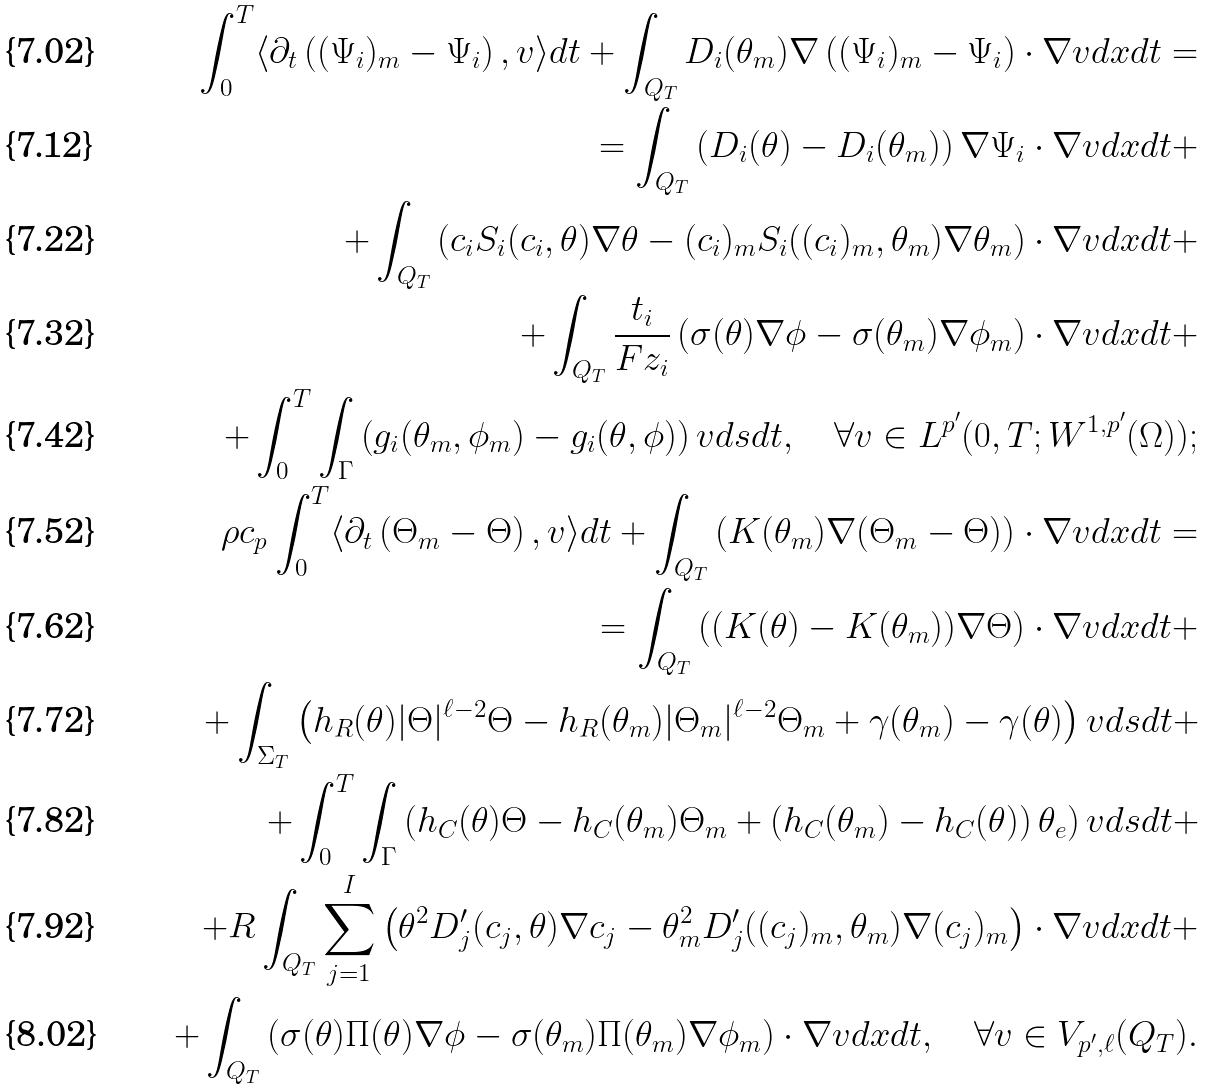Convert formula to latex. <formula><loc_0><loc_0><loc_500><loc_500>\int _ { 0 } ^ { T } \langle \partial _ { t } \left ( ( \Psi _ { i } ) _ { m } - \Psi _ { i } \right ) , v \rangle d t + \int _ { Q _ { T } } D _ { i } ( \theta _ { m } ) \nabla \left ( ( \Psi _ { i } ) _ { m } - \Psi _ { i } \right ) \cdot \nabla v d x d t = \\ = \int _ { Q _ { T } } \left ( D _ { i } ( \theta ) - D _ { i } ( \theta _ { m } ) \right ) \nabla \Psi _ { i } \cdot \nabla v d x d t + \\ + \int _ { Q _ { T } } \left ( c _ { i } S _ { i } ( c _ { i } , \theta ) \nabla \theta - ( c _ { i } ) _ { m } S _ { i } ( ( c _ { i } ) _ { m } , \theta _ { m } ) \nabla \theta _ { m } \right ) \cdot \nabla v d x d t + \\ + \int _ { Q _ { T } } \frac { t _ { i } } { F z _ { i } } \left ( \sigma ( \theta ) \nabla \phi - \sigma ( \theta _ { m } ) \nabla \phi _ { m } \right ) \cdot \nabla v d x d t + \\ + \int _ { 0 } ^ { T } \int _ { \Gamma } \left ( g _ { i } ( \theta _ { m } , \phi _ { m } ) - g _ { i } ( \theta , \phi ) \right ) v d s d t , \quad \forall v \in L ^ { p ^ { \prime } } ( 0 , T ; W ^ { 1 , p ^ { \prime } } ( \Omega ) ) ; \\ \rho c _ { p } \int _ { 0 } ^ { T } \langle \partial _ { t } \left ( \Theta _ { m } - \Theta \right ) , v \rangle d t + \int _ { Q _ { T } } \left ( K ( \theta _ { m } ) \nabla ( \Theta _ { m } - \Theta ) \right ) \cdot \nabla v d x d t = \\ = \int _ { Q _ { T } } \left ( ( K ( \theta ) - K ( \theta _ { m } ) ) \nabla \Theta \right ) \cdot \nabla v d x d t + \\ + \int _ { \Sigma _ { T } } \left ( h _ { R } ( \theta ) | \Theta | ^ { \ell - 2 } \Theta - h _ { R } ( \theta _ { m } ) | \Theta _ { m } | ^ { \ell - 2 } \Theta _ { m } + \gamma ( \theta _ { m } ) - \gamma ( \theta ) \right ) v d s d t + \\ + \int _ { 0 } ^ { T } \int _ { \Gamma } \left ( h _ { C } ( \theta ) \Theta - h _ { C } ( \theta _ { m } ) \Theta _ { m } + \left ( h _ { C } ( \theta _ { m } ) - h _ { C } ( \theta ) \right ) \theta _ { e } \right ) v d s d t + \\ + R \int _ { Q _ { T } } \sum _ { j = 1 } ^ { I } \left ( \theta ^ { 2 } D _ { j } ^ { \prime } ( c _ { j } , \theta ) \nabla c _ { j } - \theta _ { m } ^ { 2 } D _ { j } ^ { \prime } ( ( c _ { j } ) _ { m } , \theta _ { m } ) \nabla ( c _ { j } ) _ { m } \right ) \cdot \nabla v d x d t + \\ + \int _ { Q _ { T } } \left ( \sigma ( \theta ) \Pi ( \theta ) \nabla \phi - \sigma ( \theta _ { m } ) \Pi ( \theta _ { m } ) \nabla \phi _ { m } \right ) \cdot \nabla v d x d t , \quad \forall v \in V _ { p ^ { \prime } , \ell } ( Q _ { T } ) .</formula> 